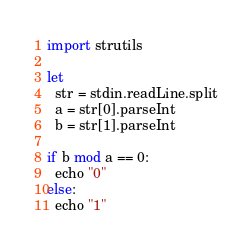<code> <loc_0><loc_0><loc_500><loc_500><_Nim_>import strutils

let
  str = stdin.readLine.split
  a = str[0].parseInt
  b = str[1].parseInt

if b mod a == 0:
  echo "0"
else:
  echo "1"
</code> 